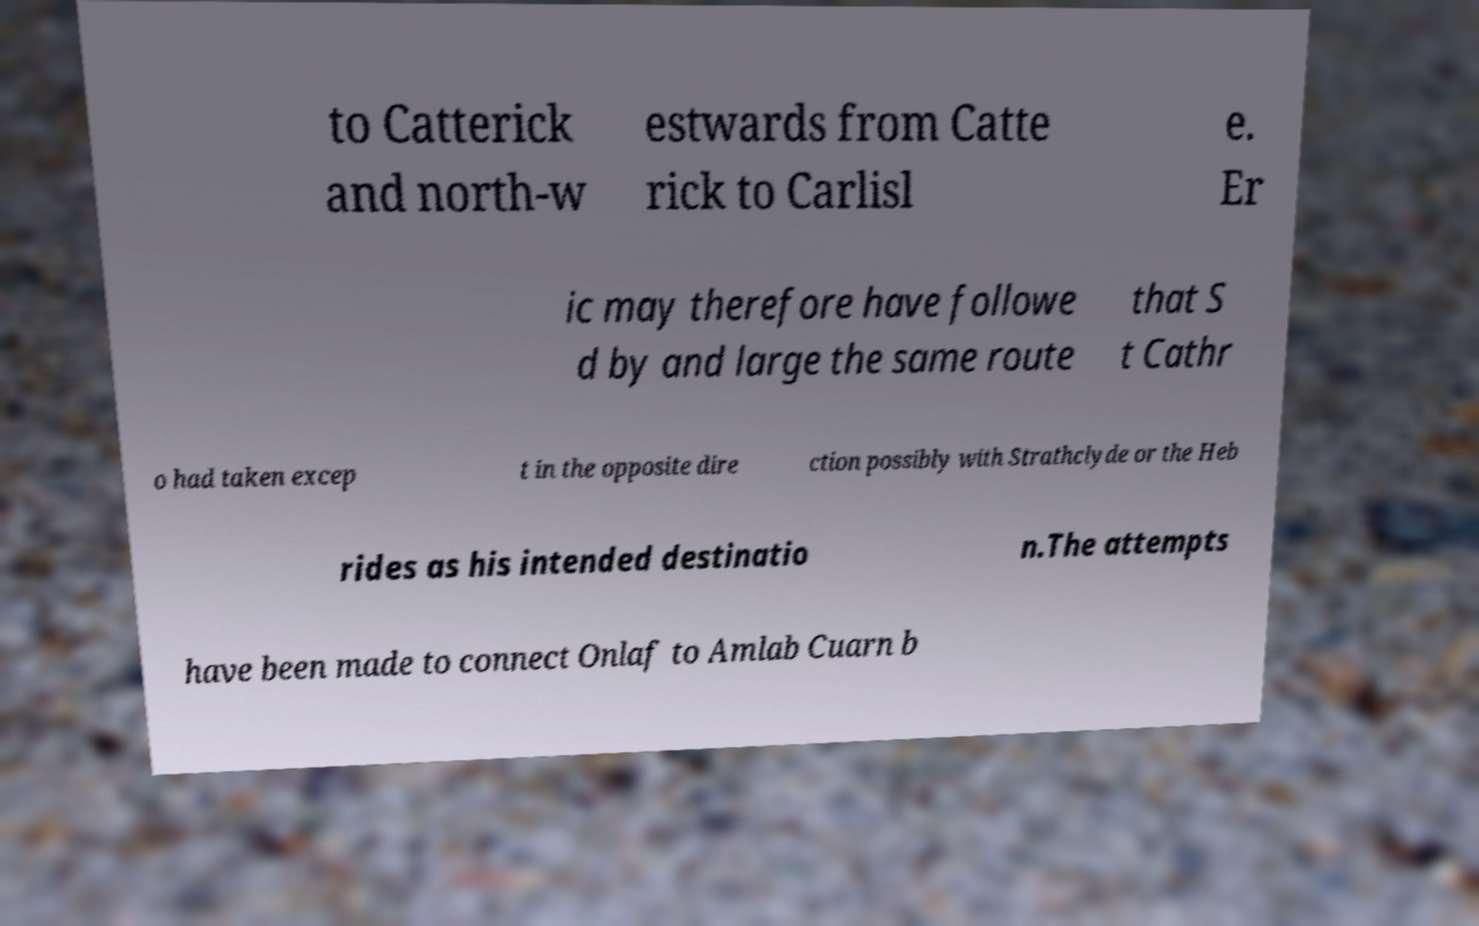Can you read and provide the text displayed in the image?This photo seems to have some interesting text. Can you extract and type it out for me? to Catterick and north-w estwards from Catte rick to Carlisl e. Er ic may therefore have followe d by and large the same route that S t Cathr o had taken excep t in the opposite dire ction possibly with Strathclyde or the Heb rides as his intended destinatio n.The attempts have been made to connect Onlaf to Amlab Cuarn b 